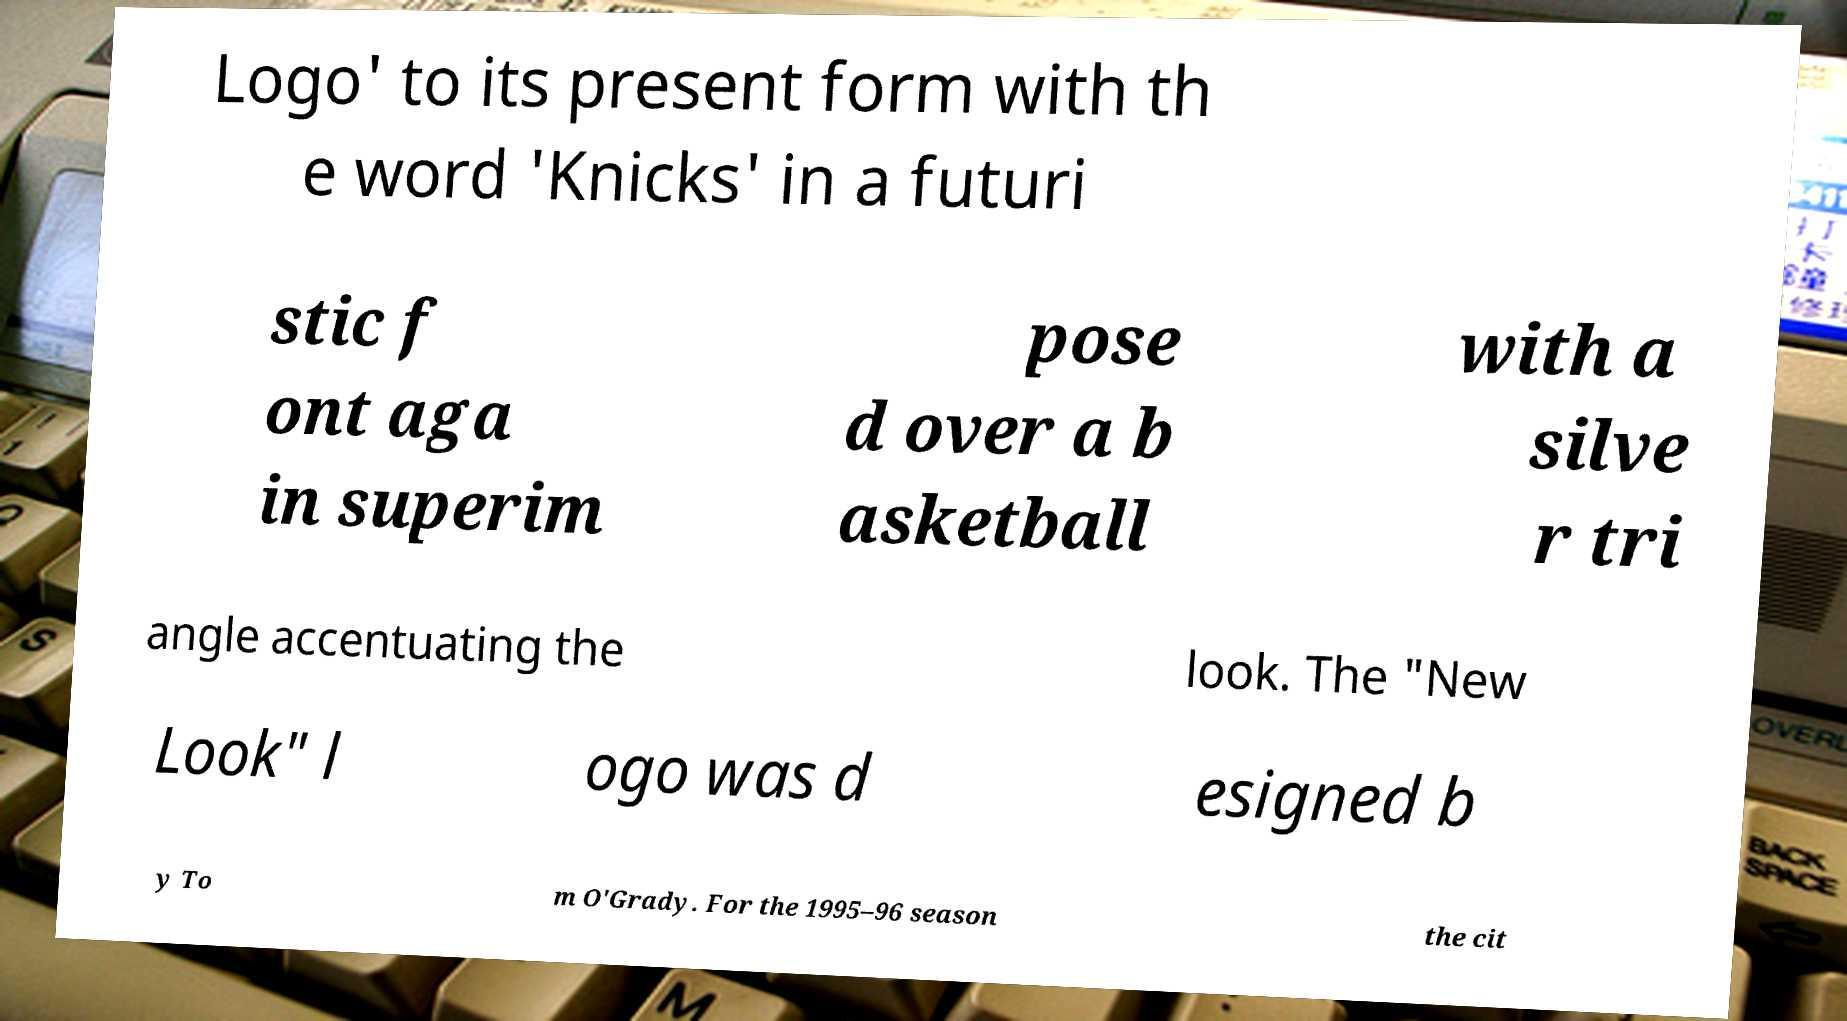Could you assist in decoding the text presented in this image and type it out clearly? Logo' to its present form with th e word 'Knicks' in a futuri stic f ont aga in superim pose d over a b asketball with a silve r tri angle accentuating the look. The "New Look" l ogo was d esigned b y To m O'Grady. For the 1995–96 season the cit 